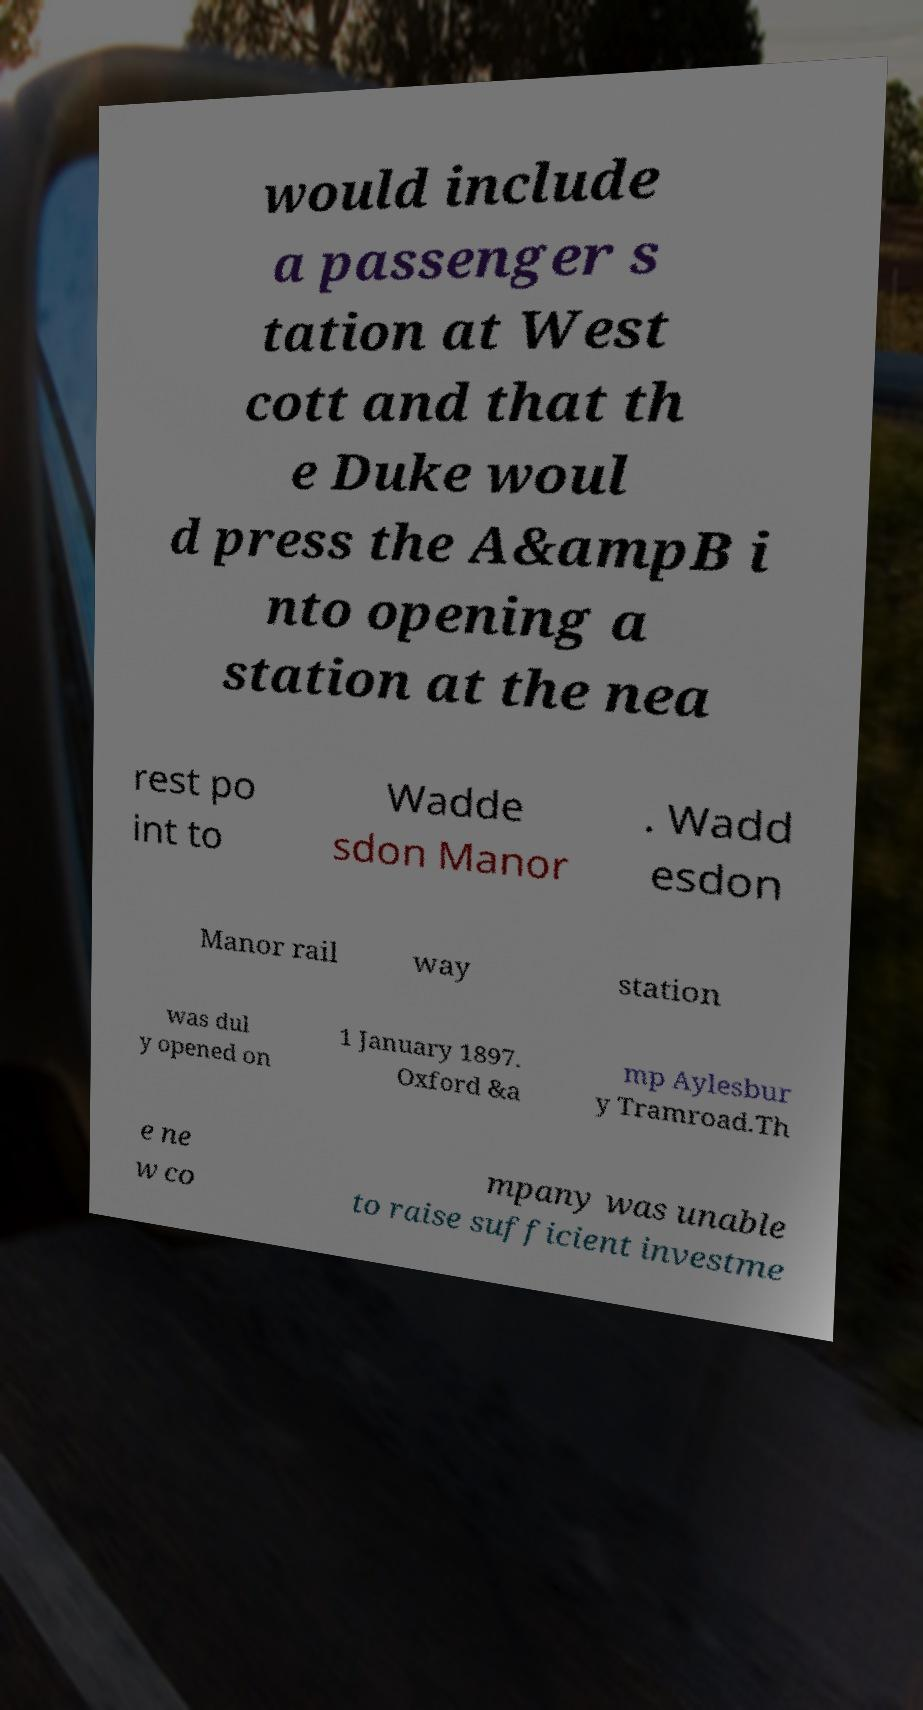Please read and relay the text visible in this image. What does it say? would include a passenger s tation at West cott and that th e Duke woul d press the A&ampB i nto opening a station at the nea rest po int to Wadde sdon Manor . Wadd esdon Manor rail way station was dul y opened on 1 January 1897. Oxford &a mp Aylesbur y Tramroad.Th e ne w co mpany was unable to raise sufficient investme 